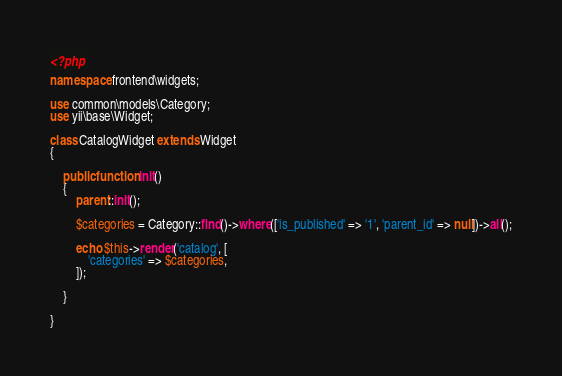<code> <loc_0><loc_0><loc_500><loc_500><_PHP_><?php

namespace frontend\widgets;

use common\models\Category;
use yii\base\Widget;

class CatalogWidget extends Widget
{

    public function init()
    {
        parent::init();

        $categories = Category::find()->where(['is_published' => '1', 'parent_id' => null])->all();

        echo $this->render('catalog', [
            'categories' => $categories,
        ]);

    }

}
</code> 